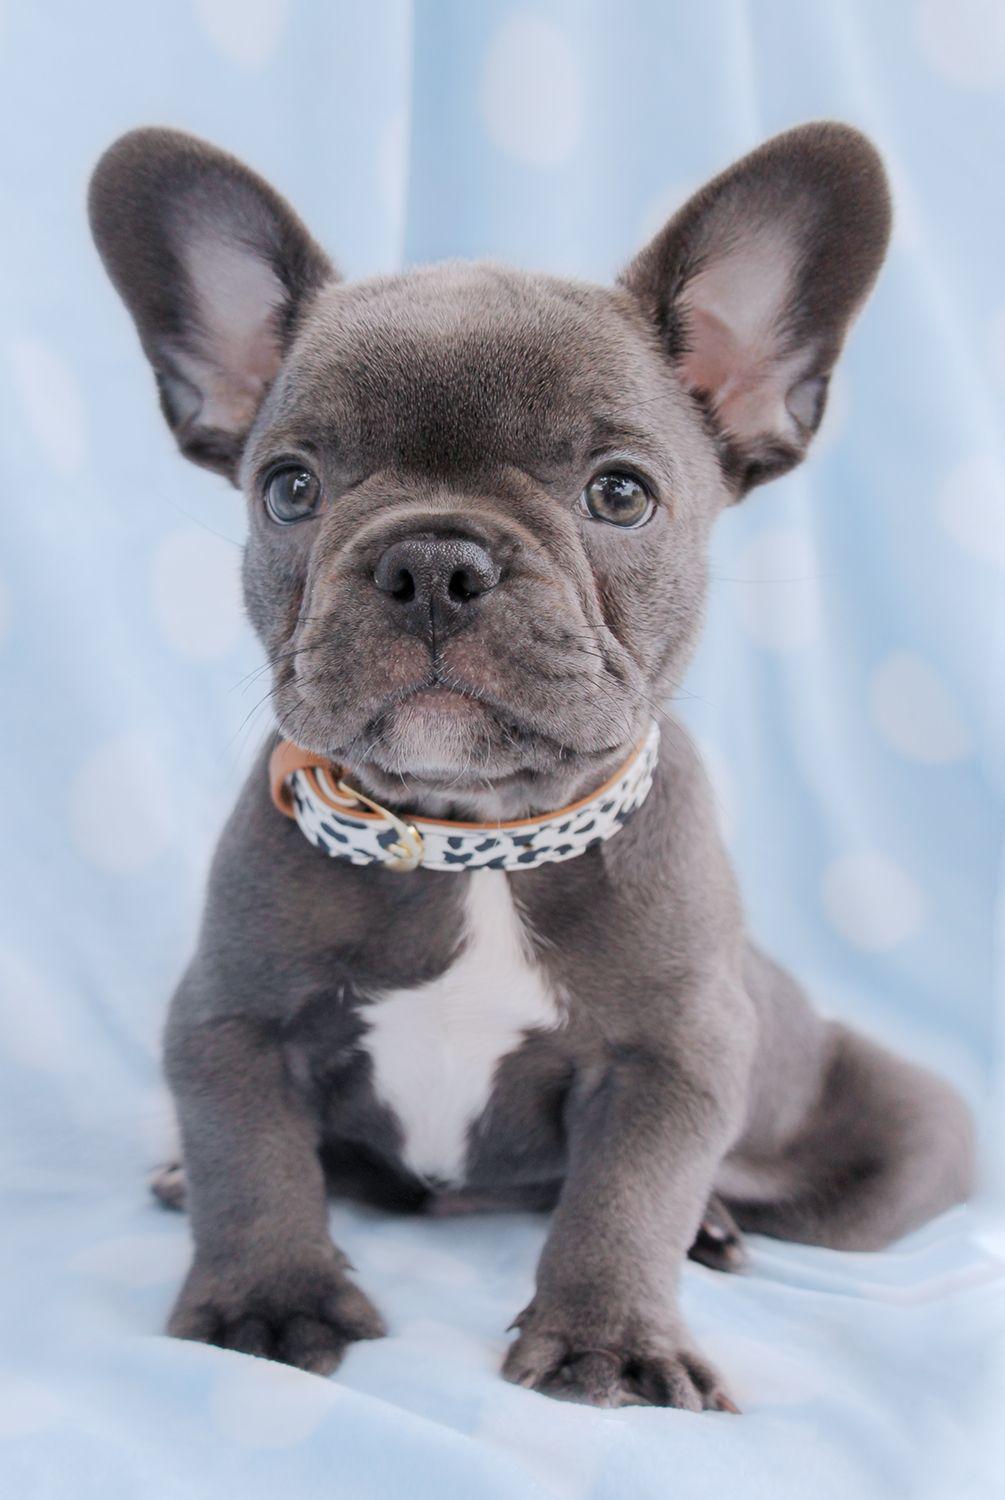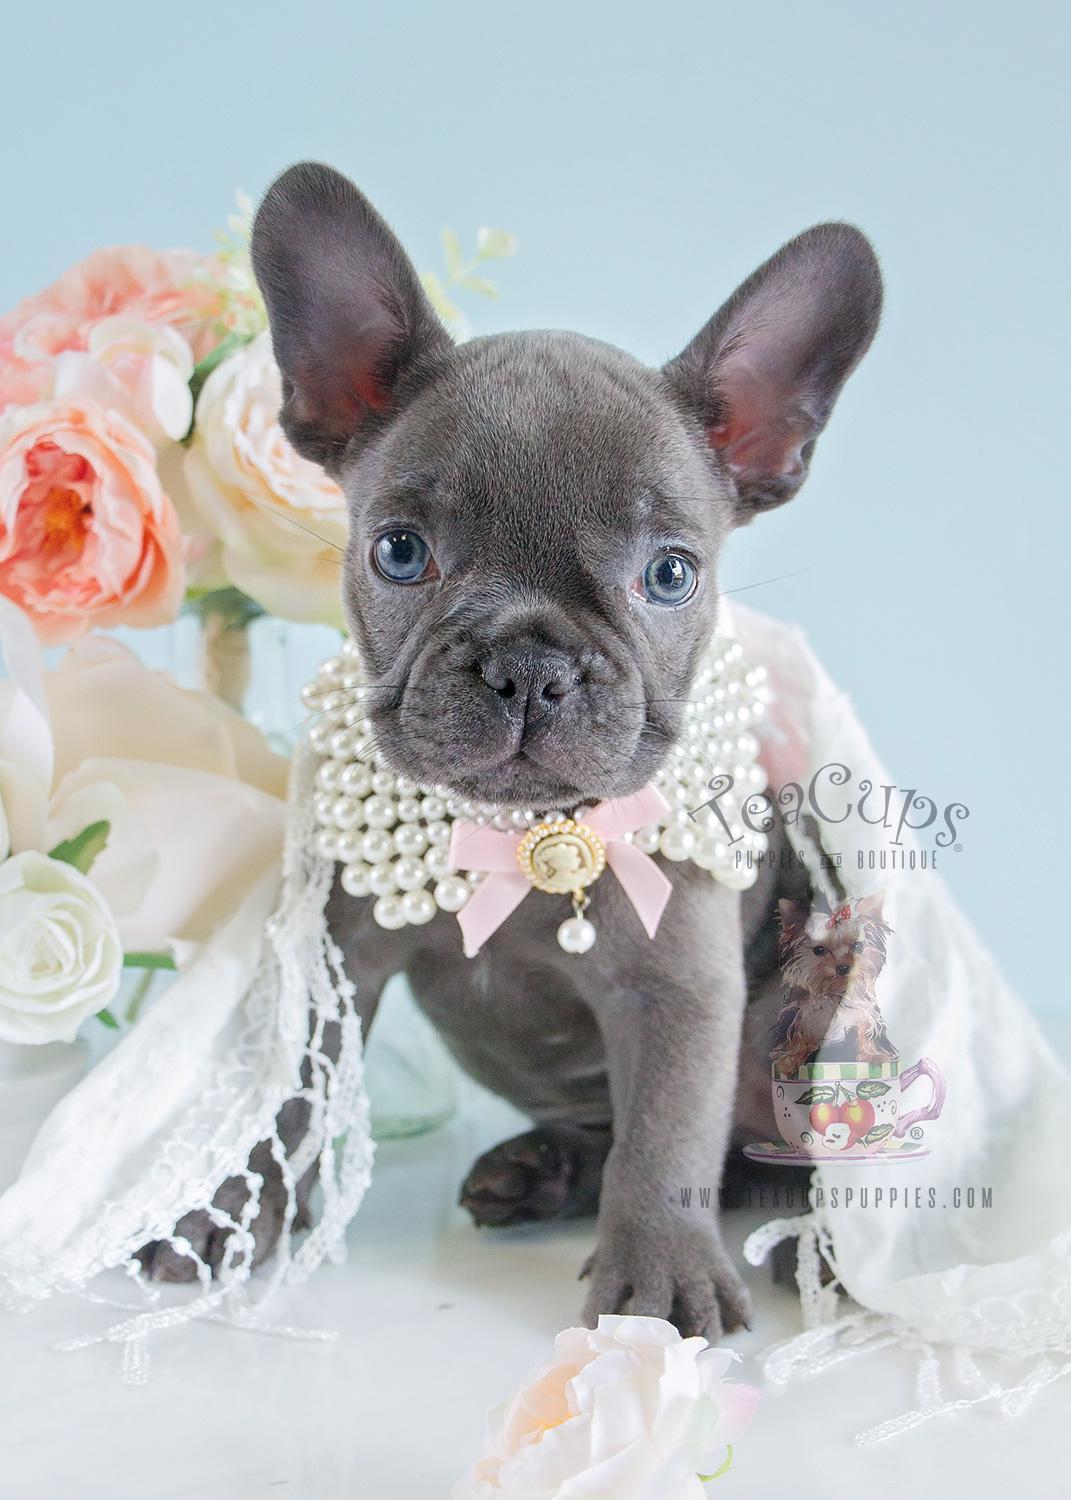The first image is the image on the left, the second image is the image on the right. Evaluate the accuracy of this statement regarding the images: "At least one dog is wearing a collar.". Is it true? Answer yes or no. Yes. The first image is the image on the left, the second image is the image on the right. For the images displayed, is the sentence "A dog is wearing a collar." factually correct? Answer yes or no. Yes. 